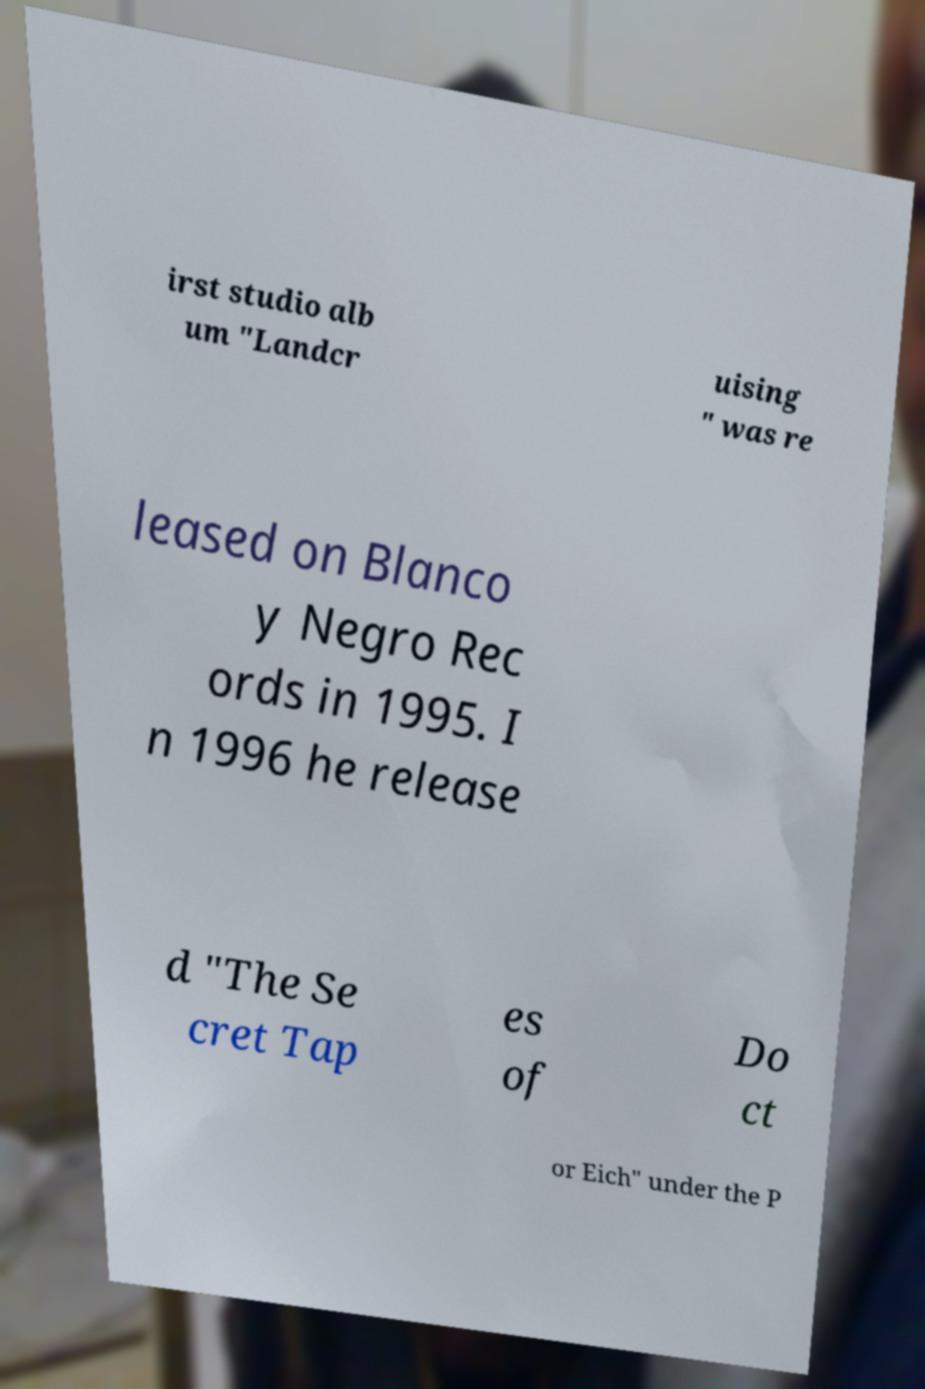Could you assist in decoding the text presented in this image and type it out clearly? irst studio alb um "Landcr uising " was re leased on Blanco y Negro Rec ords in 1995. I n 1996 he release d "The Se cret Tap es of Do ct or Eich" under the P 